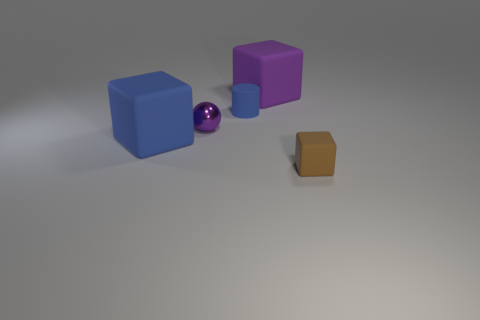Add 1 tiny blue rubber things. How many objects exist? 6 Subtract all cubes. How many objects are left? 2 Add 4 large red cylinders. How many large red cylinders exist? 4 Subtract 0 red spheres. How many objects are left? 5 Subtract all tiny purple objects. Subtract all matte cylinders. How many objects are left? 3 Add 2 large purple rubber things. How many large purple rubber things are left? 3 